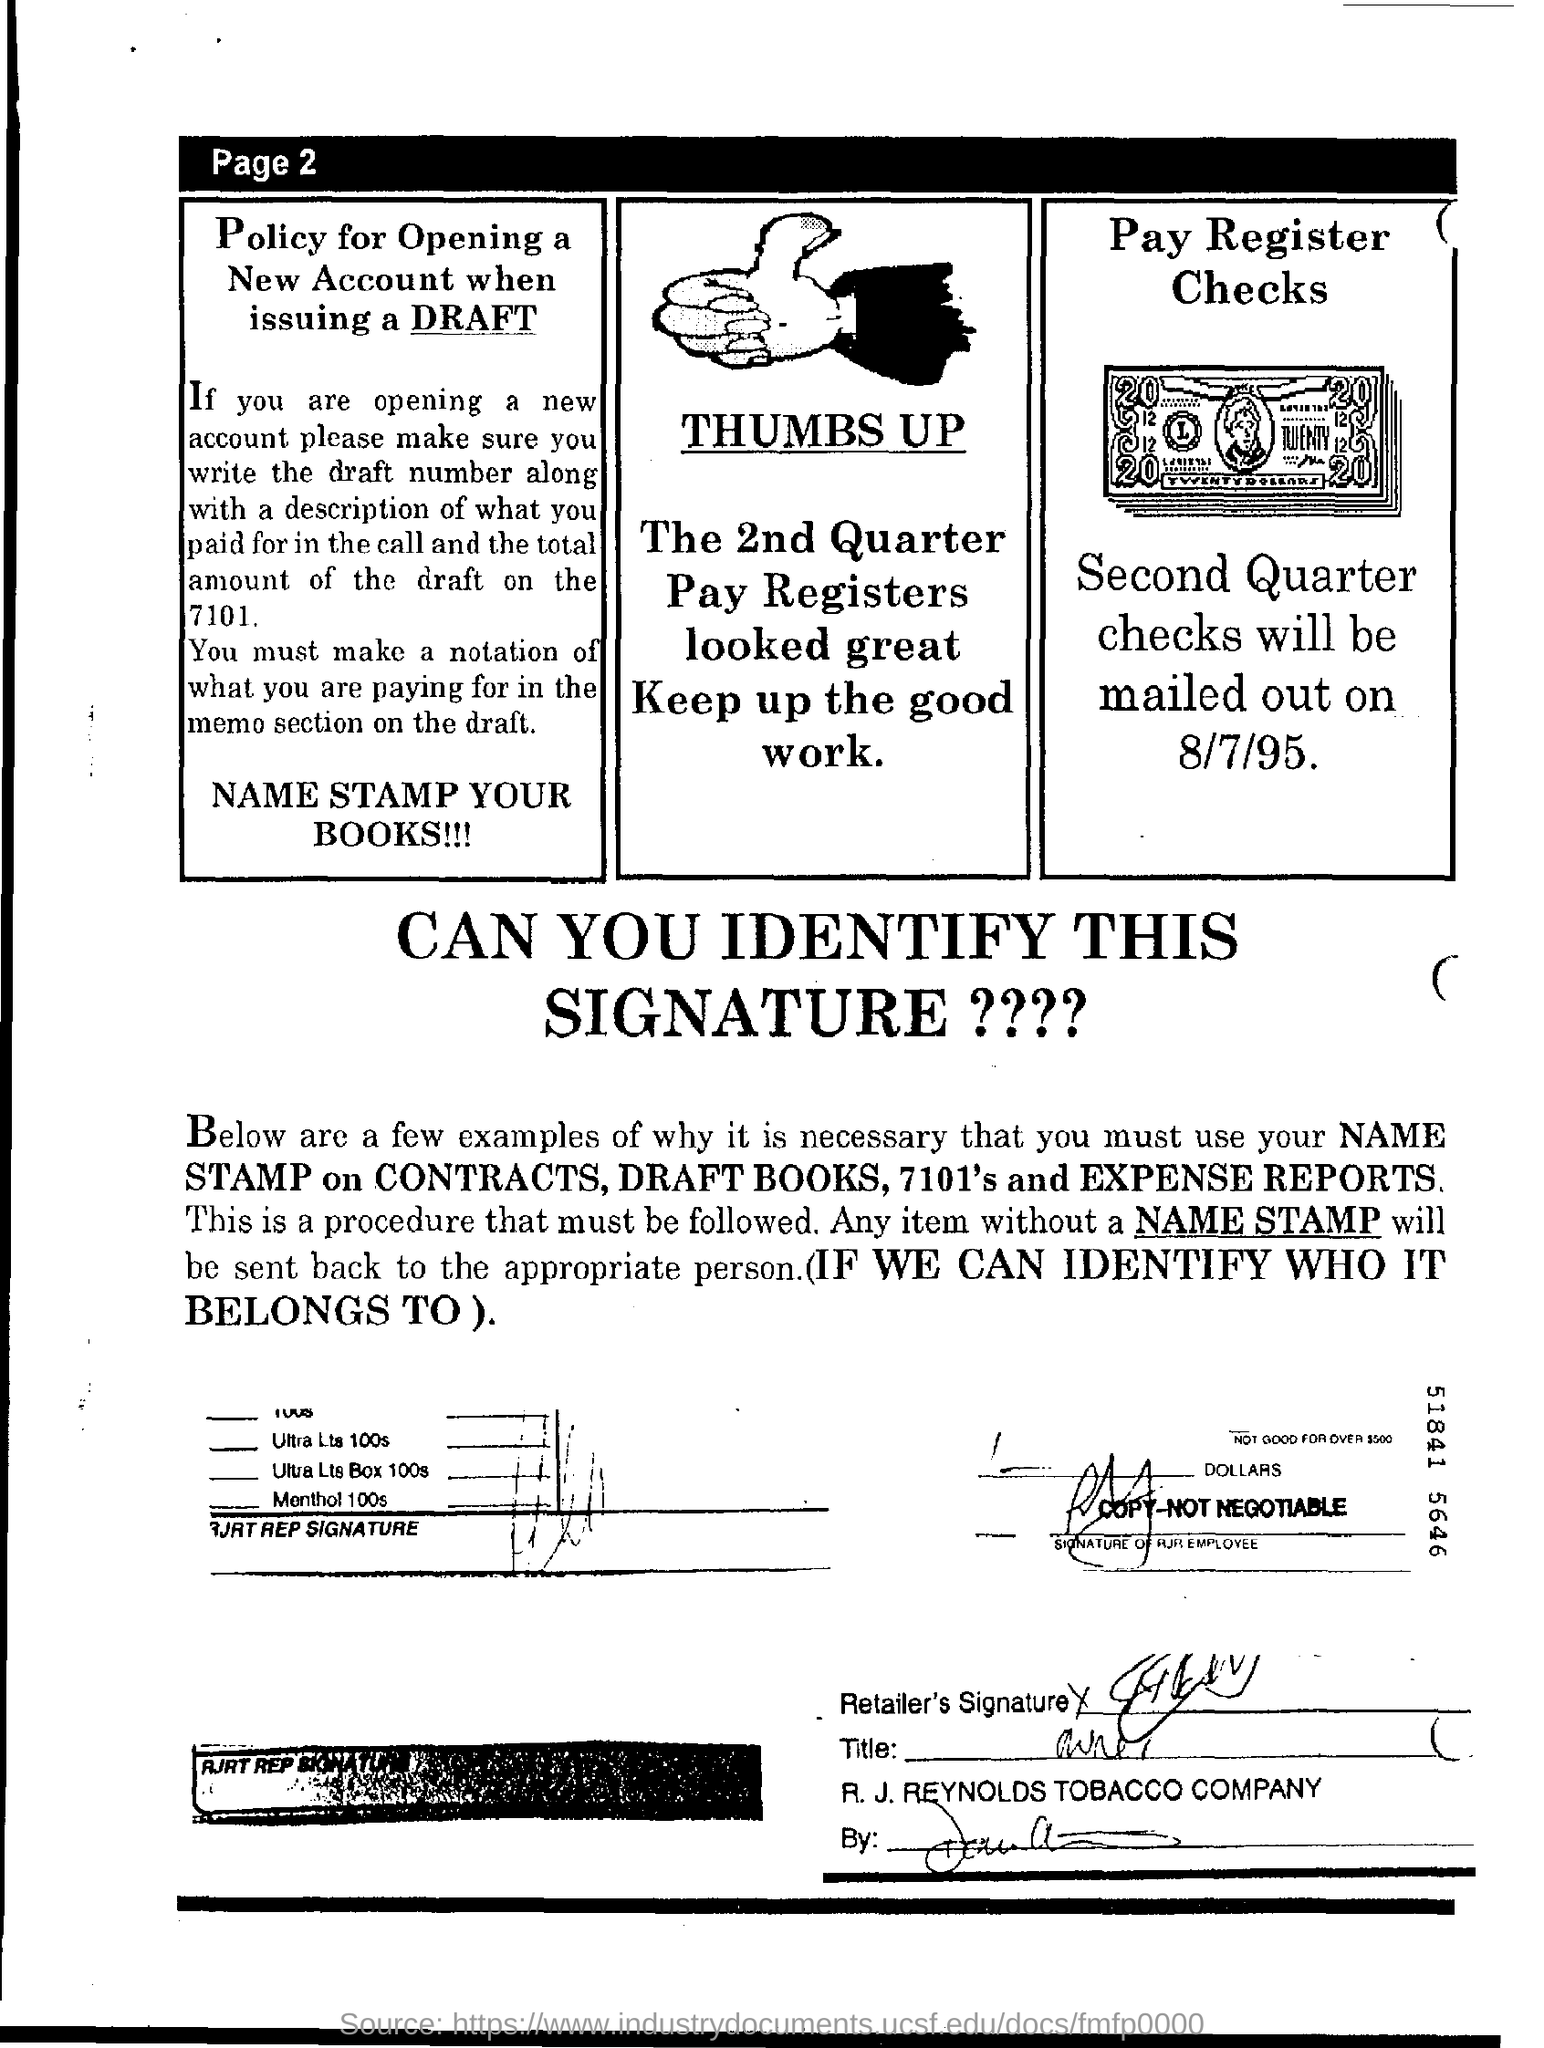Indicate a few pertinent items in this graphic. The mailing of second quarter checks will take place on August 7th, 1995. 